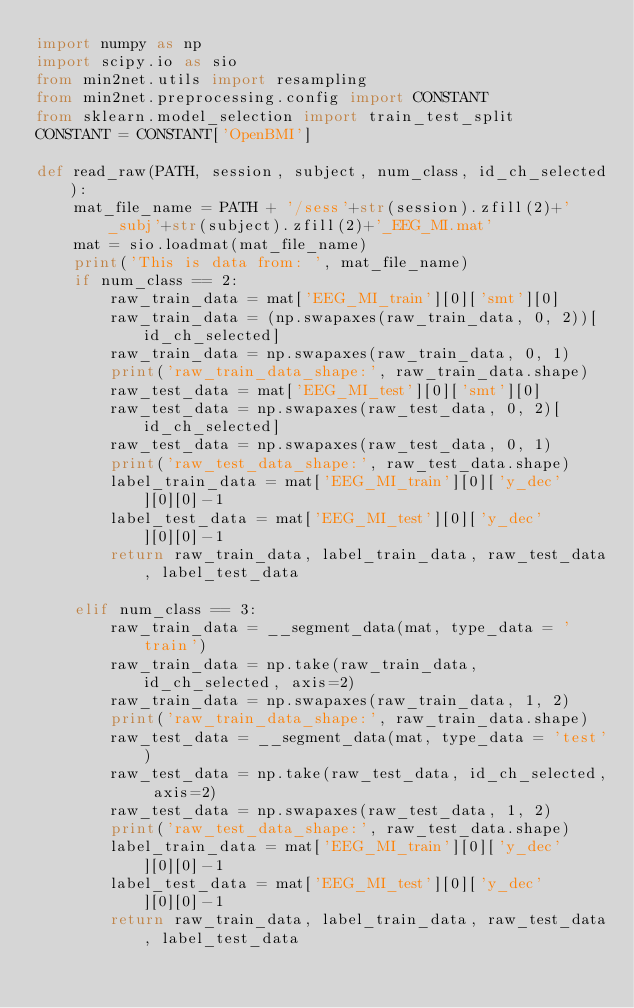<code> <loc_0><loc_0><loc_500><loc_500><_Python_>import numpy as np
import scipy.io as sio
from min2net.utils import resampling
from min2net.preprocessing.config import CONSTANT
from sklearn.model_selection import train_test_split
CONSTANT = CONSTANT['OpenBMI']

def read_raw(PATH, session, subject, num_class, id_ch_selected):
    mat_file_name = PATH + '/sess'+str(session).zfill(2)+'_subj'+str(subject).zfill(2)+'_EEG_MI.mat'
    mat = sio.loadmat(mat_file_name)
    print('This is data from: ', mat_file_name)
    if num_class == 2:
        raw_train_data = mat['EEG_MI_train'][0]['smt'][0]
        raw_train_data = (np.swapaxes(raw_train_data, 0, 2))[id_ch_selected]
        raw_train_data = np.swapaxes(raw_train_data, 0, 1)
        print('raw_train_data_shape:', raw_train_data.shape)
        raw_test_data = mat['EEG_MI_test'][0]['smt'][0]
        raw_test_data = np.swapaxes(raw_test_data, 0, 2)[id_ch_selected]
        raw_test_data = np.swapaxes(raw_test_data, 0, 1)
        print('raw_test_data_shape:', raw_test_data.shape)
        label_train_data = mat['EEG_MI_train'][0]['y_dec'][0][0]-1
        label_test_data = mat['EEG_MI_test'][0]['y_dec'][0][0]-1
        return raw_train_data, label_train_data, raw_test_data, label_test_data

    elif num_class == 3:
        raw_train_data = __segment_data(mat, type_data = 'train')
        raw_train_data = np.take(raw_train_data, id_ch_selected, axis=2)
        raw_train_data = np.swapaxes(raw_train_data, 1, 2)
        print('raw_train_data_shape:', raw_train_data.shape)
        raw_test_data = __segment_data(mat, type_data = 'test')
        raw_test_data = np.take(raw_test_data, id_ch_selected, axis=2)
        raw_test_data = np.swapaxes(raw_test_data, 1, 2)
        print('raw_test_data_shape:', raw_test_data.shape)
        label_train_data = mat['EEG_MI_train'][0]['y_dec'][0][0]-1
        label_test_data = mat['EEG_MI_test'][0]['y_dec'][0][0]-1
        return raw_train_data, label_train_data, raw_test_data, label_test_data
    </code> 